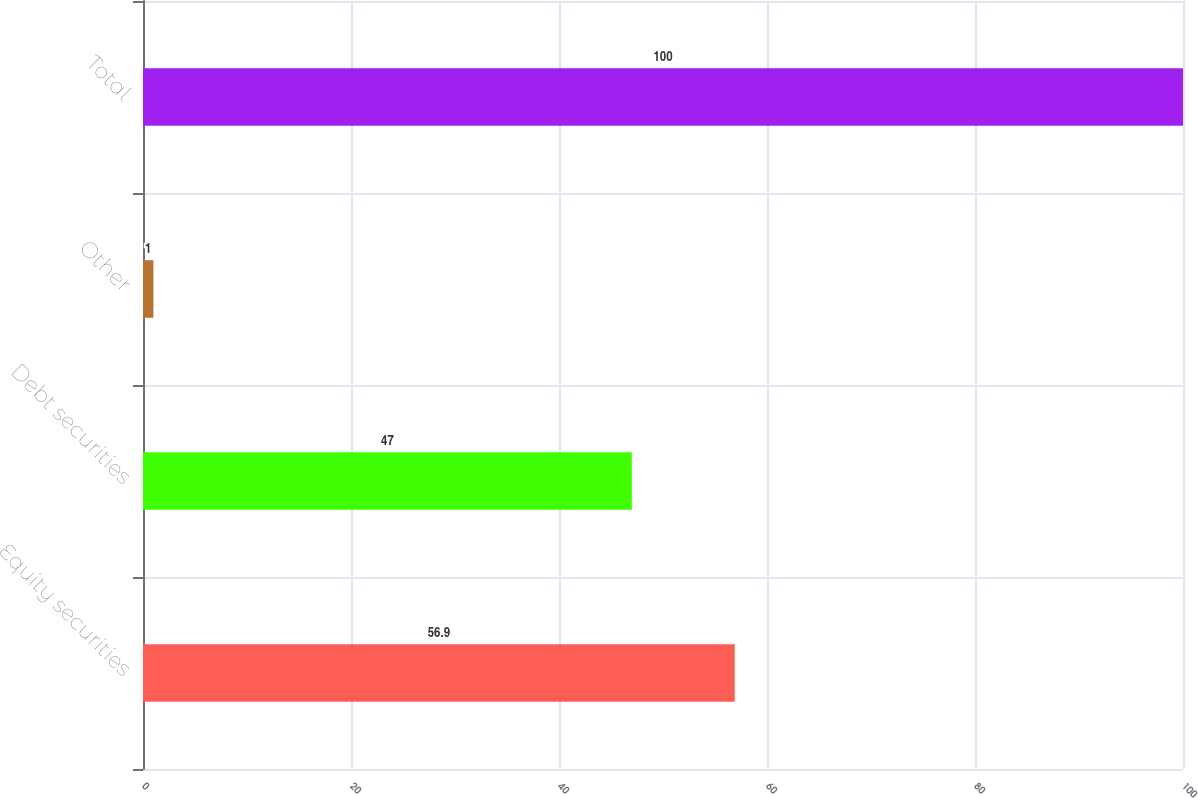Convert chart to OTSL. <chart><loc_0><loc_0><loc_500><loc_500><bar_chart><fcel>Equity securities<fcel>Debt securities<fcel>Other<fcel>Total<nl><fcel>56.9<fcel>47<fcel>1<fcel>100<nl></chart> 